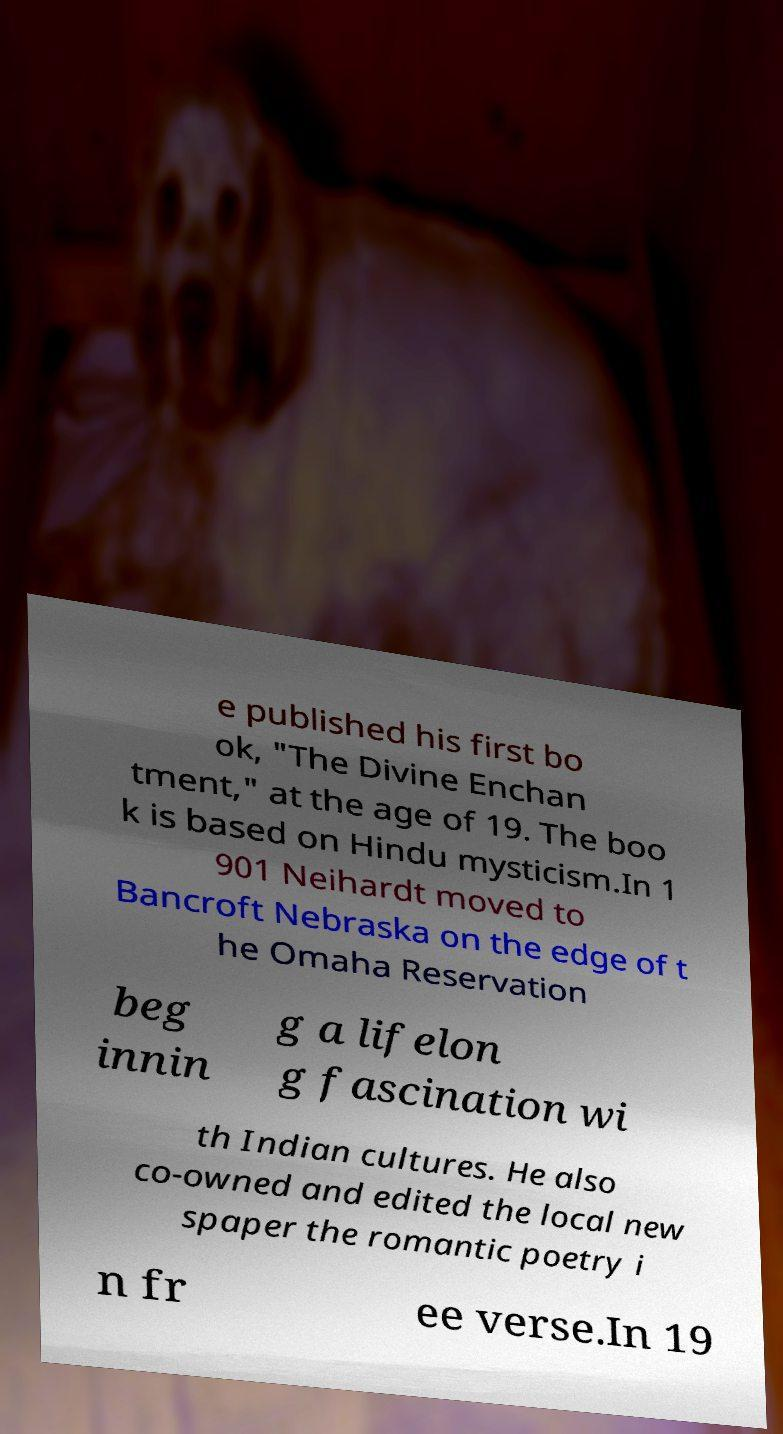Please read and relay the text visible in this image. What does it say? e published his first bo ok, "The Divine Enchan tment," at the age of 19. The boo k is based on Hindu mysticism.In 1 901 Neihardt moved to Bancroft Nebraska on the edge of t he Omaha Reservation beg innin g a lifelon g fascination wi th Indian cultures. He also co-owned and edited the local new spaper the romantic poetry i n fr ee verse.In 19 